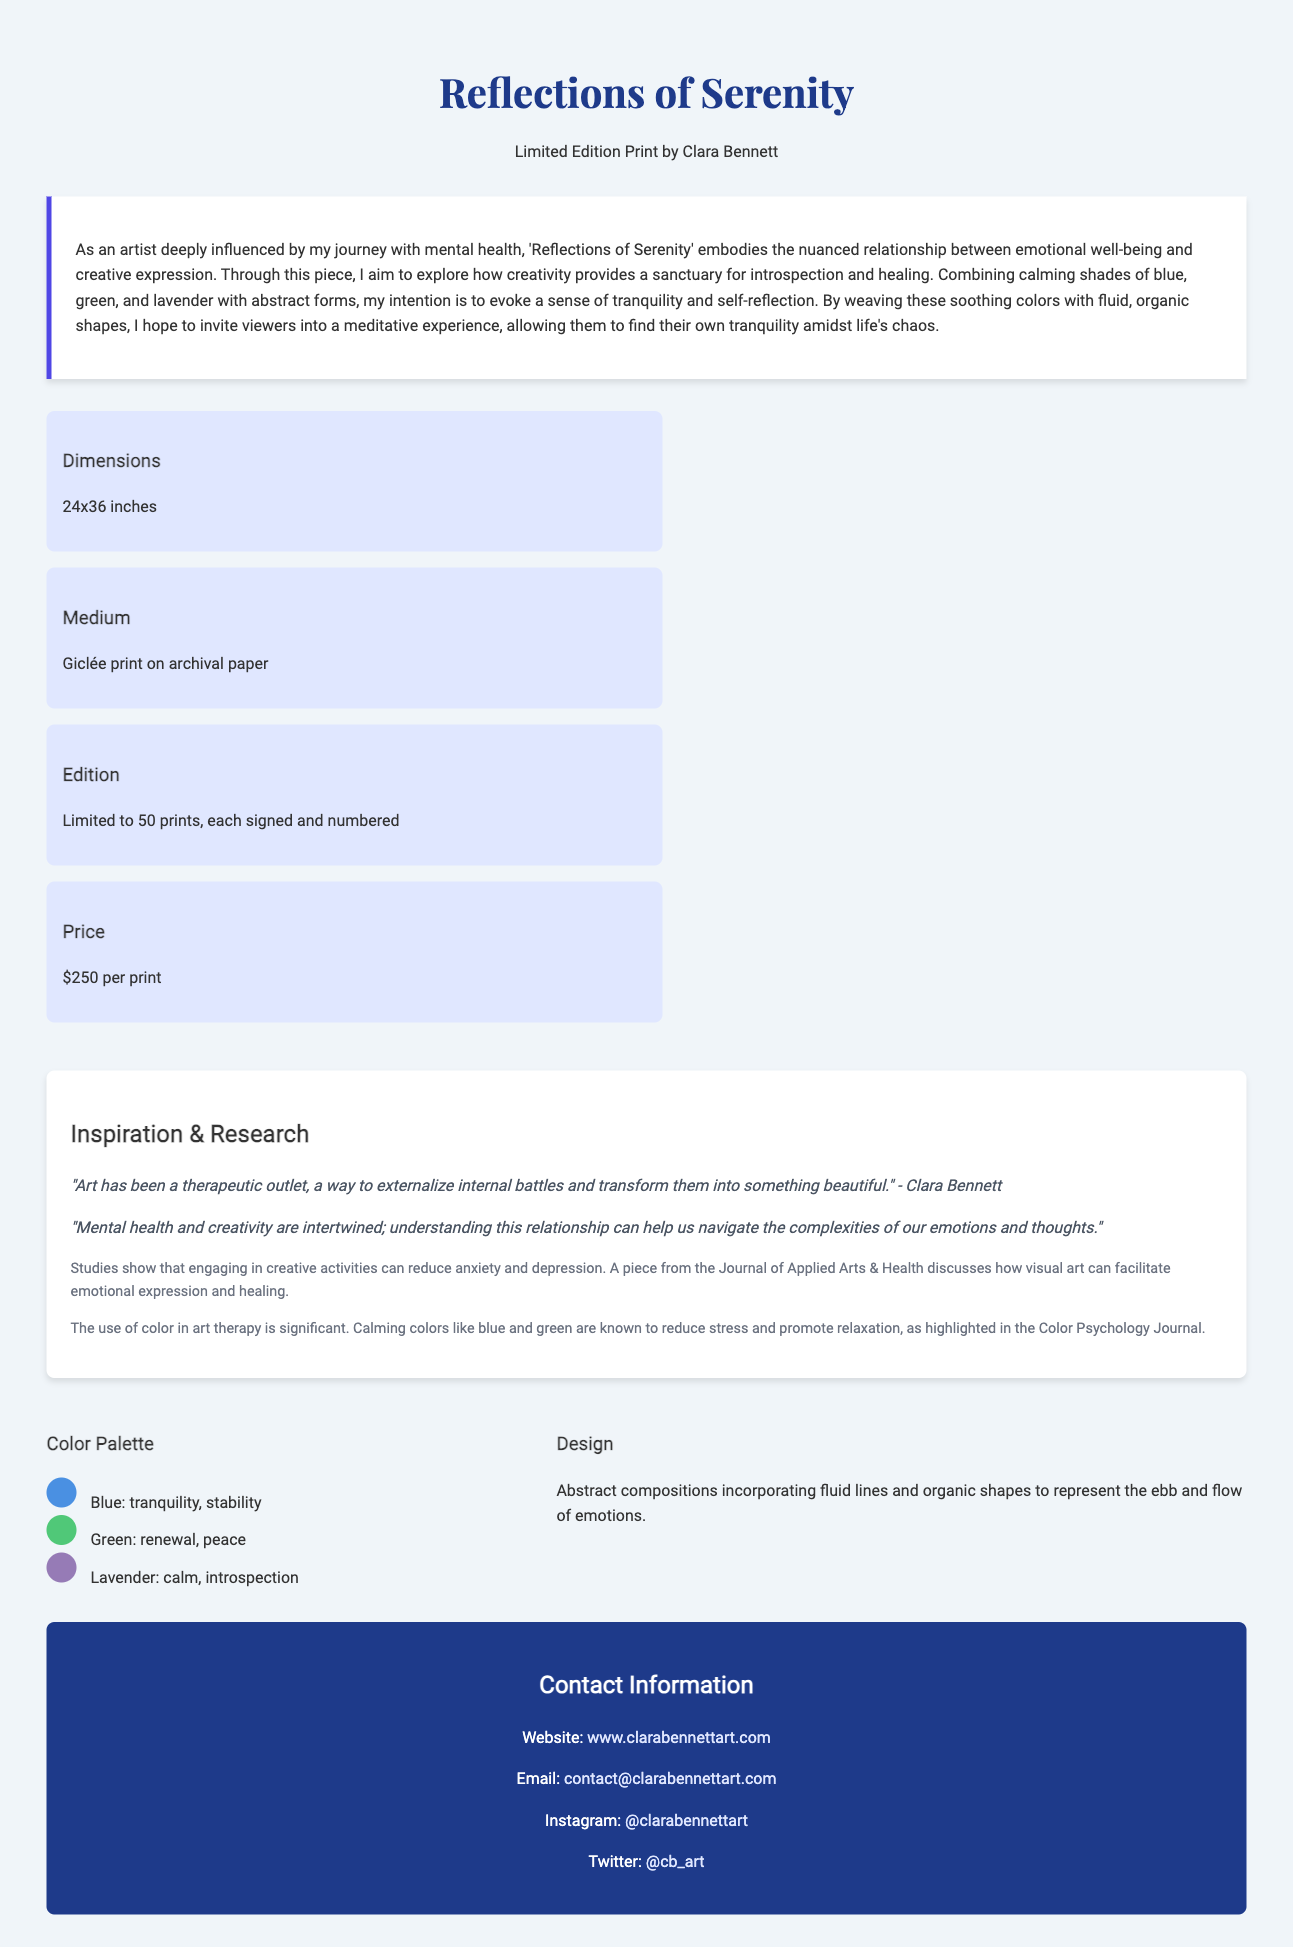what is the title of the print? The title of the print is found in the header section of the document.
Answer: Reflections of Serenity who is the artist? The artist of the print is mentioned directly below the title in the header section.
Answer: Clara Bennett how many prints are available in this edition? The limited edition information is provided in the details section of the document.
Answer: 50 prints what are the dimensions of the print? The dimensions are specified in the details section of the document.
Answer: 24x36 inches what is the price of each print? The price is listed in the details section of the document.
Answer: $250 per print which colors are included in the artwork's color palette? The colors are highlighted in the visual elements section of the document.
Answer: Blue, Green, Lavender how does the artist describe the interplay between creativity and mental health? The artist discusses this relationship in the artist statement section of the document.
Answer: Creativity provides a sanctuary for introspection and healing what type of print is used for the artwork? The medium is stated in the details section of the document.
Answer: Giclée print on archival paper what is the main purpose of the artist's statement? The purpose can be inferred from the content of the artist statement section.
Answer: To explore the relationship between emotional well-being and creative expression 